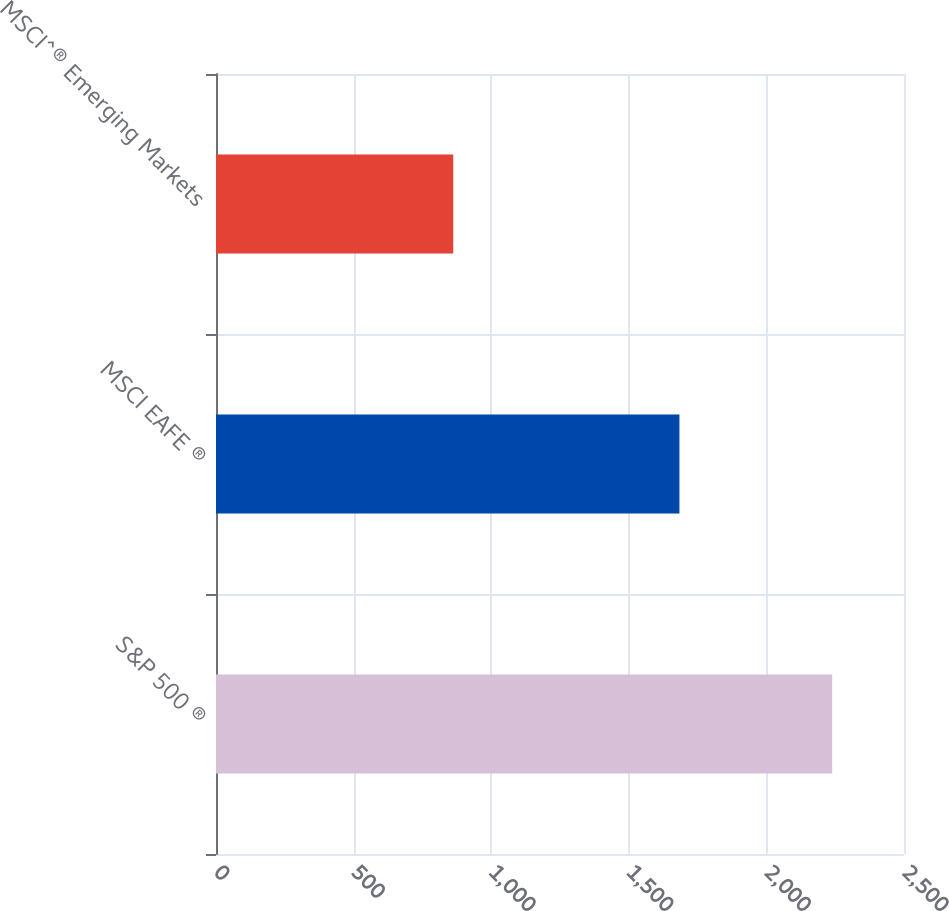Convert chart. <chart><loc_0><loc_0><loc_500><loc_500><bar_chart><fcel>S&P 500 ®<fcel>MSCI EAFE ®<fcel>MSCI^® Emerging Markets<nl><fcel>2239<fcel>1684<fcel>862<nl></chart> 